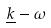<formula> <loc_0><loc_0><loc_500><loc_500>\underline { k } - \omega</formula> 